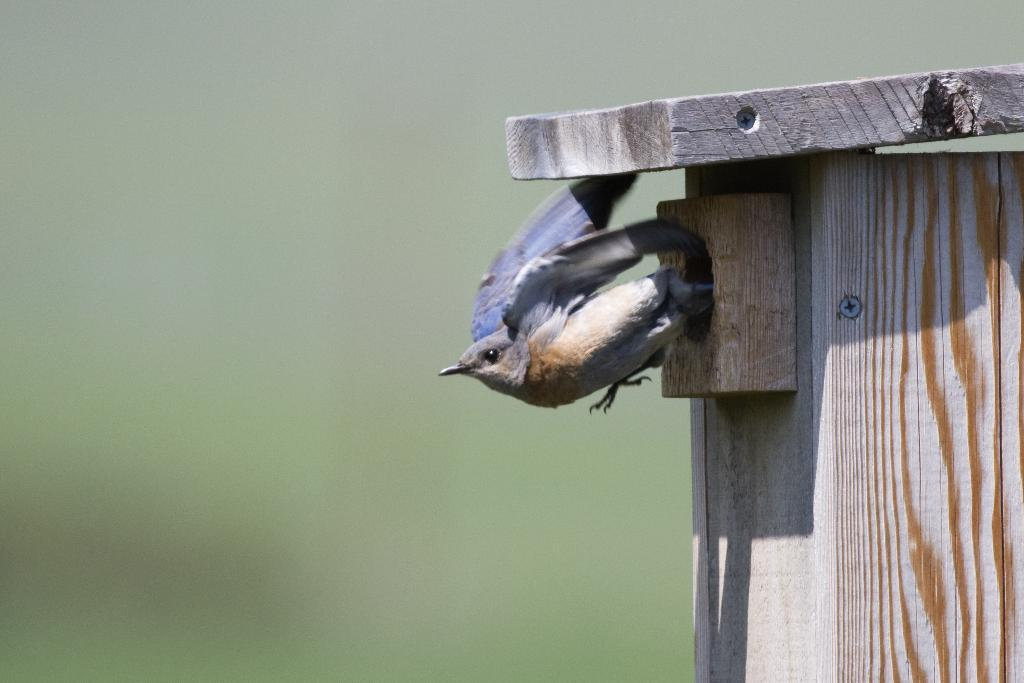What type of animal can be seen in the image? There is a bird in the image. What material is the object made of in the image? There is a wooden object in the image. What type of request does the bird make in the image? There is no indication in the image that the bird is making any request. What is the texture of the bird's feathers in the image? The image does not provide enough detail to determine the texture of the bird's feathers. 